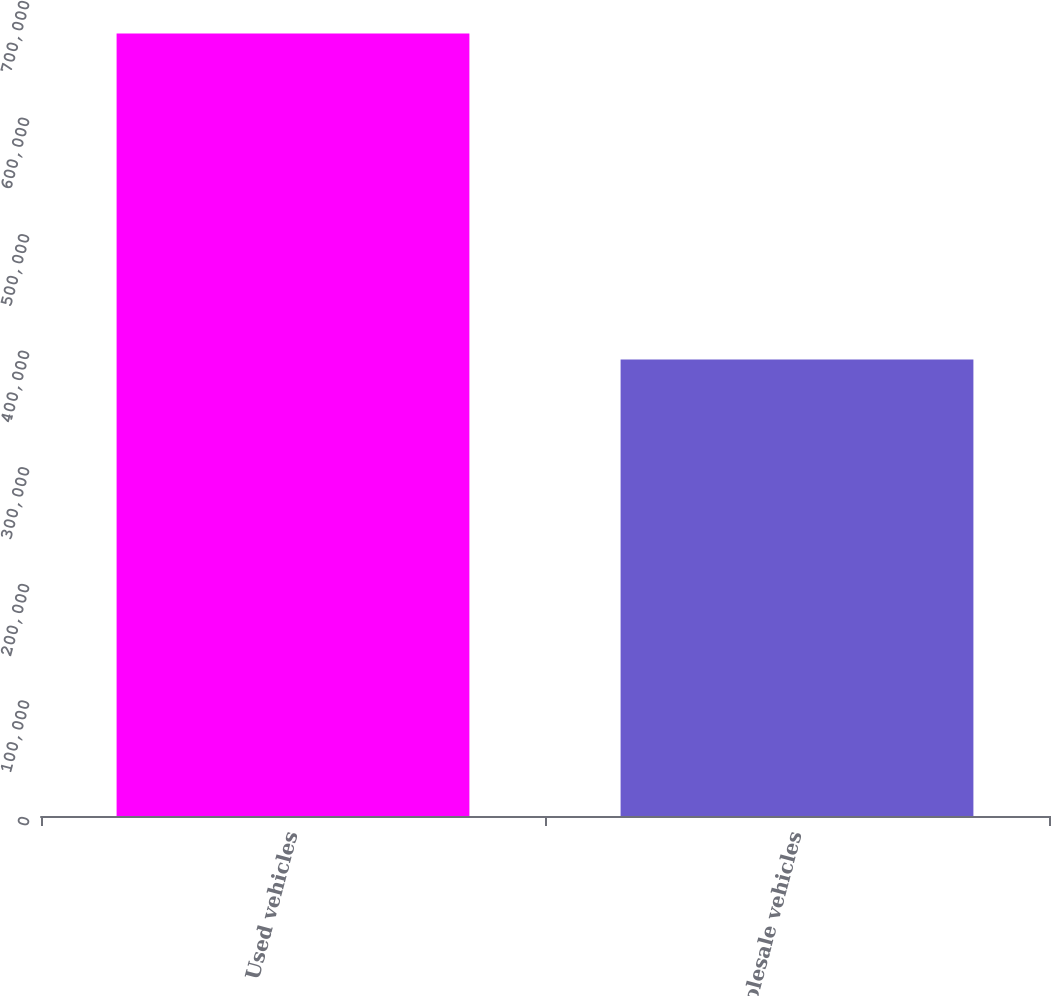<chart> <loc_0><loc_0><loc_500><loc_500><bar_chart><fcel>Used vehicles<fcel>Wholesale vehicles<nl><fcel>671294<fcel>391686<nl></chart> 